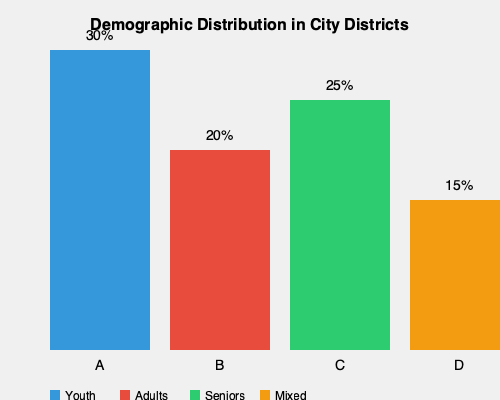Based on the demographic distribution chart of city districts, which two districts would you recommend for establishing new community centers to serve the largest and most diverse population? To determine the best locations for community centers, we need to consider both the population size and diversity of each district. Let's analyze the data step-by-step:

1. Population size:
   District A: 30%
   District B: 20%
   District C: 25%
   District D: 15%

2. Demographic composition:
   District A: Predominantly youth
   District B: Predominantly adults
   District C: Predominantly seniors
   District D: Mixed population

3. Analysis:
   - District A has the largest population (30%) but is mainly composed of youth.
   - District C has the second-largest population (25%) and is mainly composed of seniors.
   - District B has a significant population (20%) of predominantly adults.
   - District D has the smallest population (15%) but offers the most diverse mix.

4. Decision-making:
   - To serve the largest population, we should consider District A.
   - To ensure diversity, we should include either District C or District D.
   - District C offers a larger population than District D, making it a better choice.

5. Conclusion:
   Establishing community centers in Districts A and C would serve the largest and most diverse population:
   - District A (30%) caters to the youth demographic.
   - District C (25%) serves the senior population.
   - Combined, these districts represent 55% of the total population and cover two distinct age groups.

This combination ensures both high coverage and demographic diversity, making the community centers accessible and beneficial to a wide range of residents.
Answer: Districts A and C 